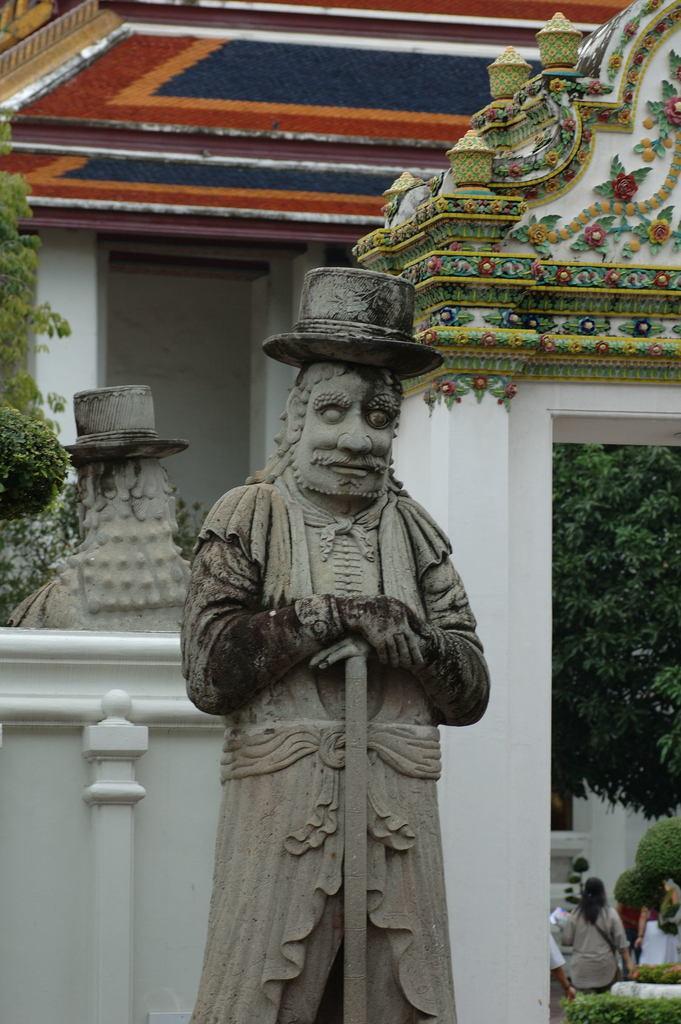Describe this image in one or two sentences. In this image there is a building truncated towards the top of the image, there is a window, there is the wall, there is a tree truncated towards the left of the image, there is a tree truncated towards the right of the image, there are persons, there is a sculptor, there are plants truncated towards the bottom of the image. 